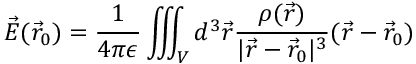<formula> <loc_0><loc_0><loc_500><loc_500>\vec { E } ( \vec { r } _ { 0 } ) = \frac { 1 } { 4 \pi \epsilon } \iiint _ { V } d ^ { 3 } \vec { r } \frac { \rho ( \vec { r } ) } { | \vec { r } - \vec { r } _ { 0 } | ^ { 3 } } ( \vec { r } - \vec { r } _ { 0 } )</formula> 